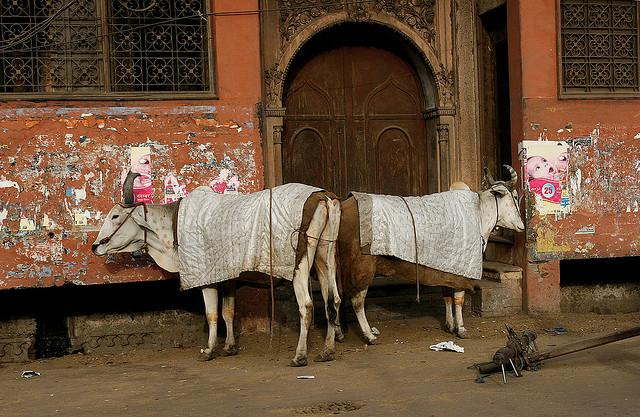Are these cows or goats?
Keep it brief. Cows. Is there a baby in the pictures on the wall?
Write a very short answer. Yes. Is it sunny?
Keep it brief. Yes. Is this white horse drinking water?
Quick response, please. No. What are these animals?
Quick response, please. Cows. What is the design of the entryway?
Be succinct. Archway. 